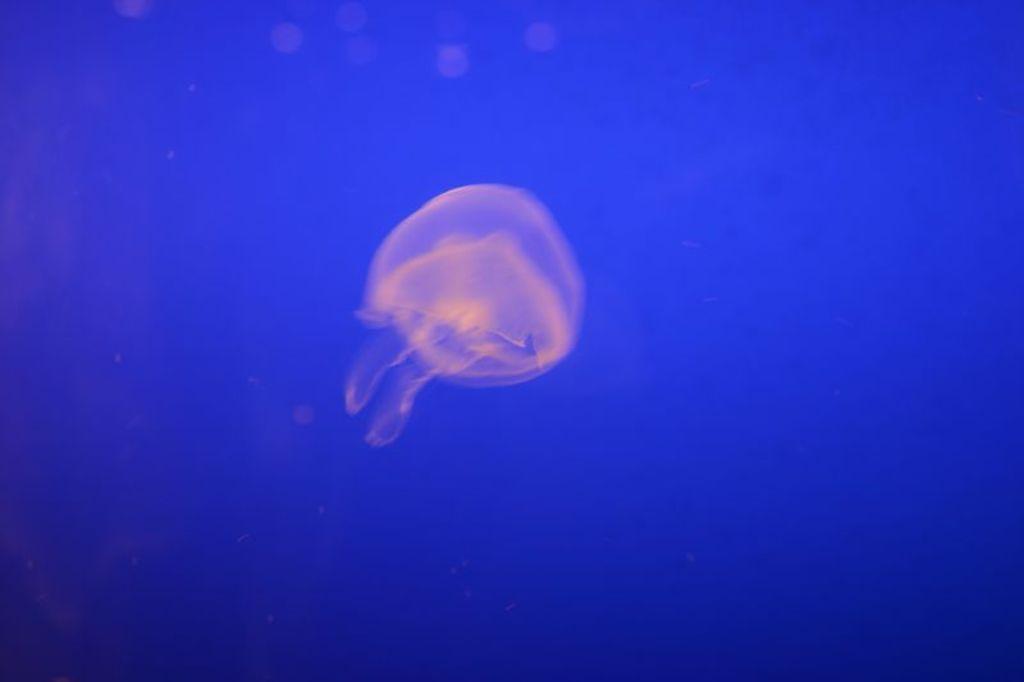Please provide a concise description of this image. A Jelly fish is swimming in the water. 